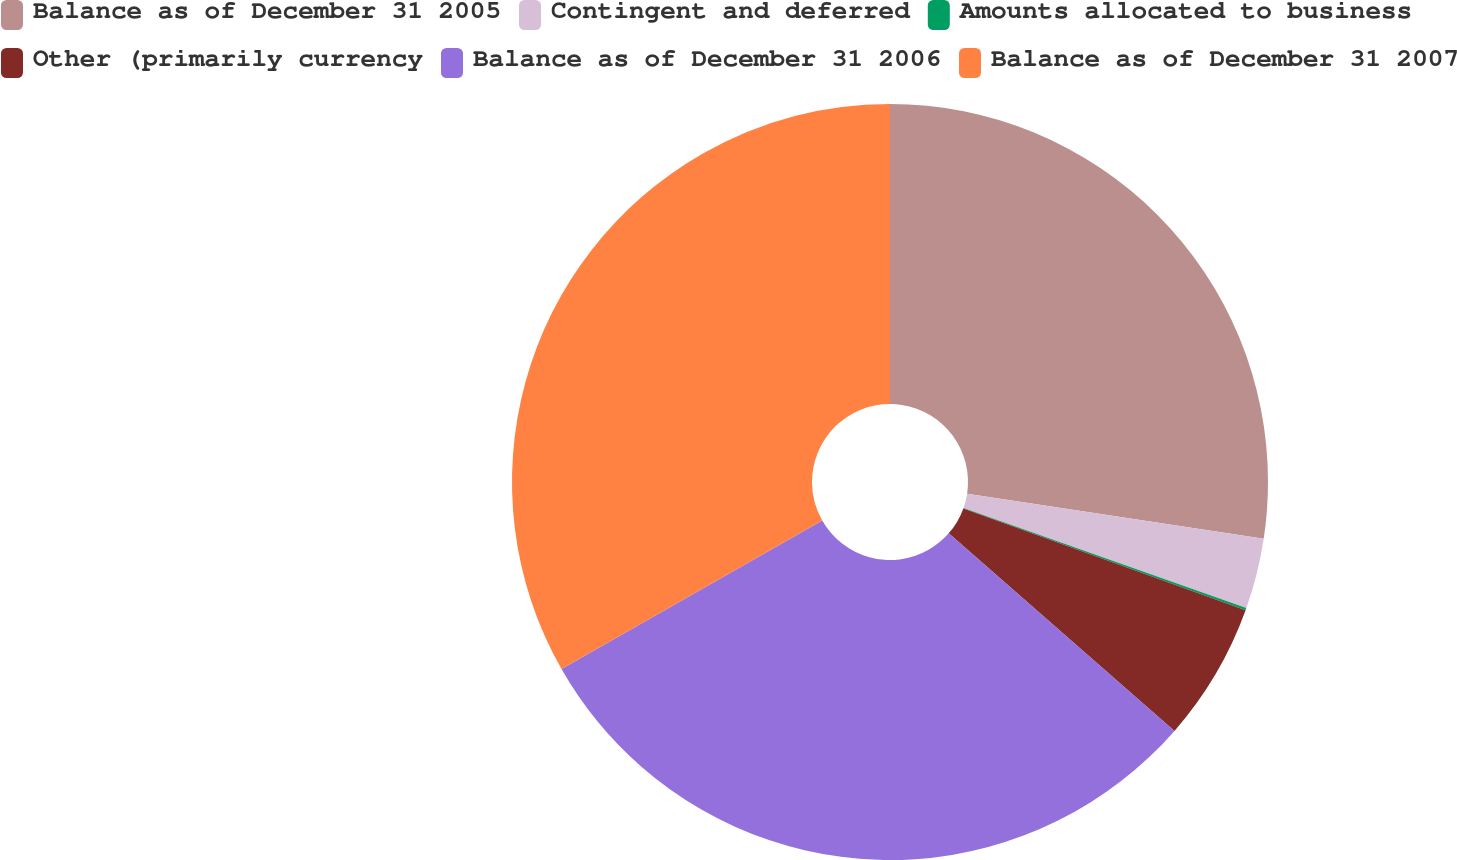Convert chart to OTSL. <chart><loc_0><loc_0><loc_500><loc_500><pie_chart><fcel>Balance as of December 31 2005<fcel>Contingent and deferred<fcel>Amounts allocated to business<fcel>Other (primarily currency<fcel>Balance as of December 31 2006<fcel>Balance as of December 31 2007<nl><fcel>27.4%<fcel>3.01%<fcel>0.1%<fcel>5.93%<fcel>30.32%<fcel>33.24%<nl></chart> 